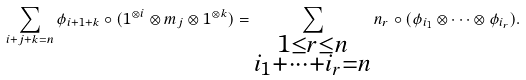<formula> <loc_0><loc_0><loc_500><loc_500>\sum _ { i + j + k = n } \phi _ { i + 1 + k } \circ ( 1 ^ { \otimes i } \otimes m _ { j } \otimes 1 ^ { \otimes k } ) = \sum _ { \substack { 1 \leq r \leq n \\ i _ { 1 } + \dots + i _ { r } = n } } n _ { r } \circ ( \phi _ { i _ { 1 } } \otimes \cdots \otimes \phi _ { i _ { r } } ) .</formula> 